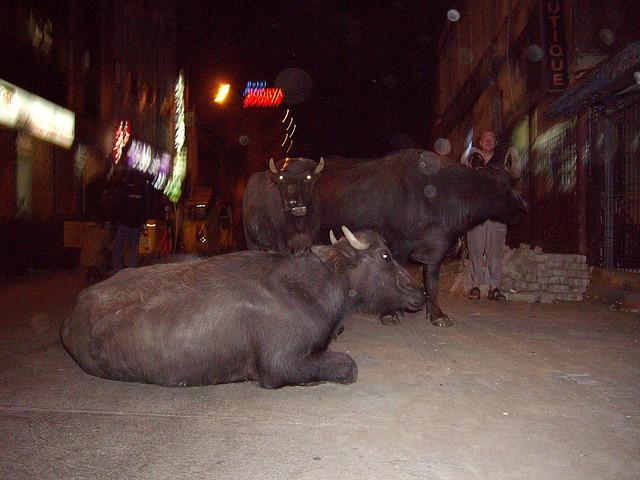Where is the animal currently sitting? street 